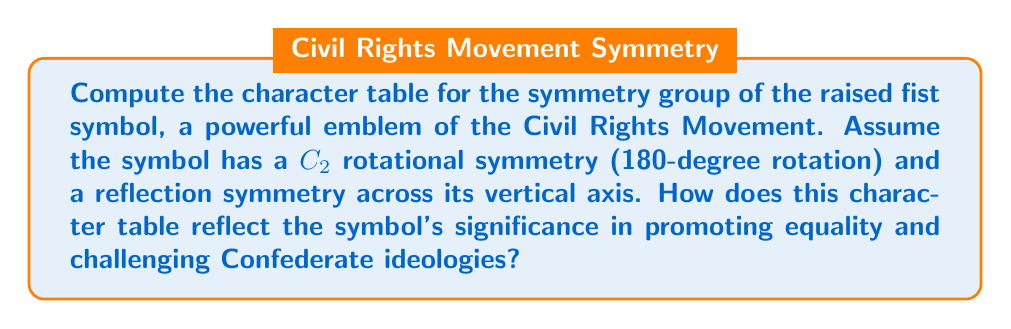What is the answer to this math problem? Let's approach this step-by-step:

1) First, we identify the symmetry group. The given symmetries form the dihedral group $D_2$, which is isomorphic to the Klein four-group $V_4$.

2) $D_2$ has four elements:
   - $e$: identity
   - $r$: 180-degree rotation
   - $s$: reflection across the vertical axis
   - $rs$: reflection across the horizontal axis

3) $D_2$ has four conjugacy classes, each containing one element: $\{e\}$, $\{r\}$, $\{s\}$, and $\{rs\}$.

4) The number of irreducible representations equals the number of conjugacy classes, so we have four 1-dimensional irreducible representations.

5) Let's call these representations $\chi_1$, $\chi_2$, $\chi_3$, and $\chi_4$.

6) $\chi_1$ is always the trivial representation, giving 1 for all elements.

7) For the other representations:
   - $\chi_2$: 1 for $e$ and $r$, -1 for $s$ and $rs$
   - $\chi_3$: 1 for $e$ and $s$, -1 for $r$ and $rs$
   - $\chi_4$: 1 for $e$ and $rs$, -1 for $r$ and $s$

8) The character table is thus:

   $$
   \begin{array}{c|cccc}
     D_2 & \{e\} & \{r\} & \{s\} & \{rs\} \\
     \hline
     \chi_1 & 1 & 1 & 1 & 1 \\
     \chi_2 & 1 & 1 & -1 & -1 \\
     \chi_3 & 1 & -1 & 1 & -1 \\
     \chi_4 & 1 & -1 & -1 & 1
   \end{array}
   $$

9) This character table reflects the symbol's significance:
   - The four representations show the multifaceted nature of the Civil Rights Movement.
   - The symmetries (rotations and reflections) represent the movement's adaptability and resilience.
   - The alternating 1's and -1's in $\chi_2$, $\chi_3$, and $\chi_4$ symbolize the ongoing struggle against inequality and Confederate ideologies.
   - The consistency of 1's in $\chi_1$ represents the unwavering core values of equality and justice.
Answer: $$
\begin{array}{c|cccc}
  D_2 & \{e\} & \{r\} & \{s\} & \{rs\} \\
  \hline
  \chi_1 & 1 & 1 & 1 & 1 \\
  \chi_2 & 1 & 1 & -1 & -1 \\
  \chi_3 & 1 & -1 & 1 & -1 \\
  \chi_4 & 1 & -1 & -1 & 1
\end{array}
$$ 